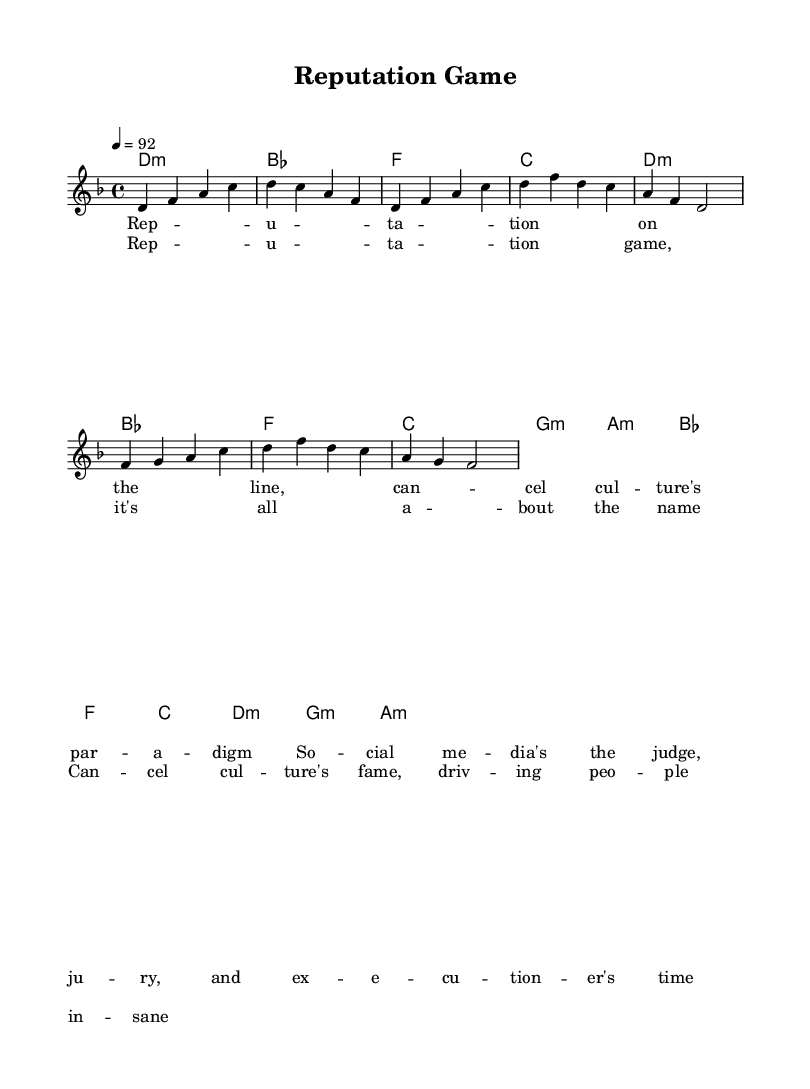What is the key signature of this music? The key signature is D minor, which contains one flat (B flat). This can be identified in the global settings of the score.
Answer: D minor What is the time signature of this music? The time signature is 4/4, which can be seen in the global settings of the score. It indicates that there are four beats in each measure.
Answer: 4/4 What is the tempo marking of the music? The tempo marking is 92 beats per minute, indicated in the global section as "4 = 92." This tells the performer how fast to play the piece.
Answer: 92 How many measures are there in the verse section? The verse section consists of four measures, as indicated by the notation in the melody part. Each group of notes separated by vertical lines represents one measure.
Answer: 4 What is the main theme of the chorus? The chorus centers around the ideas of reputation and the consequences of cancel culture, which can be gleaned from the lyrics provided. It reflects on sanity and the fame associated with cancel culture.
Answer: Reputation game What type of chord progression is used in the chorus? The chorus uses a major chord progression with the chords B flat, F, C, and D minor, which can be identified from the harmonic structure. The presence of the B flat major chord at the beginning also signifies a shift in tonality that maintains harmony.
Answer: Major chord progression What musical style does this piece represent? This piece is a rap, indicated by its lyrical content focusing on social themes and its rhythmical phrasing that aligns with hip-hop anthems. The use of spoken and rhythmic lyrics is characteristic of rap music.
Answer: Rap 